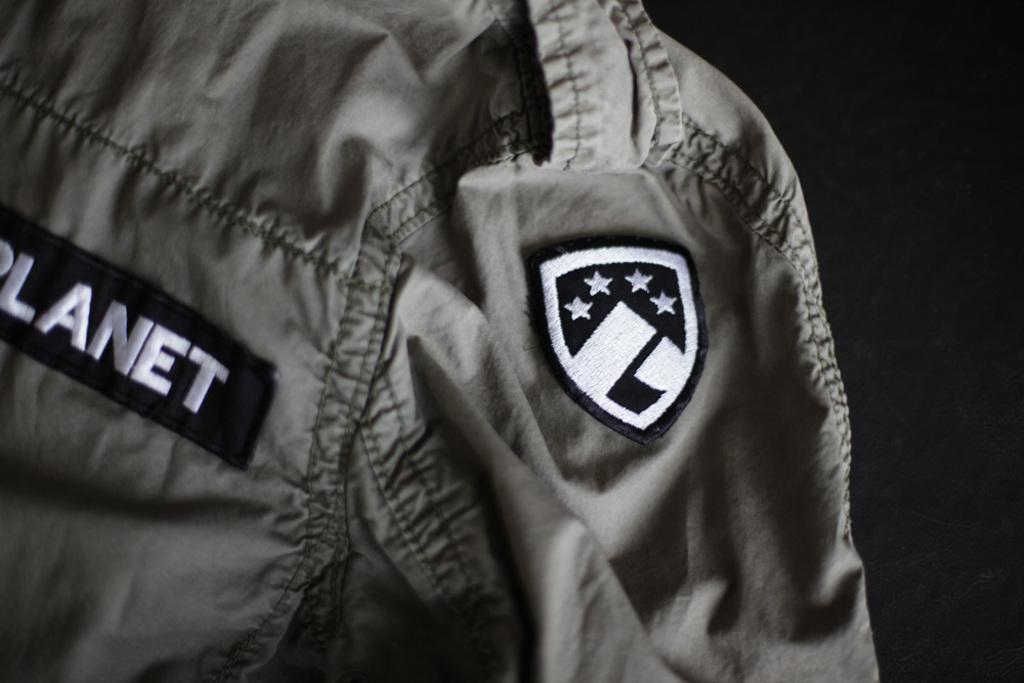Provide a one-sentence caption for the provided image. The word planet can be seen on a jacket with a patch on it. 